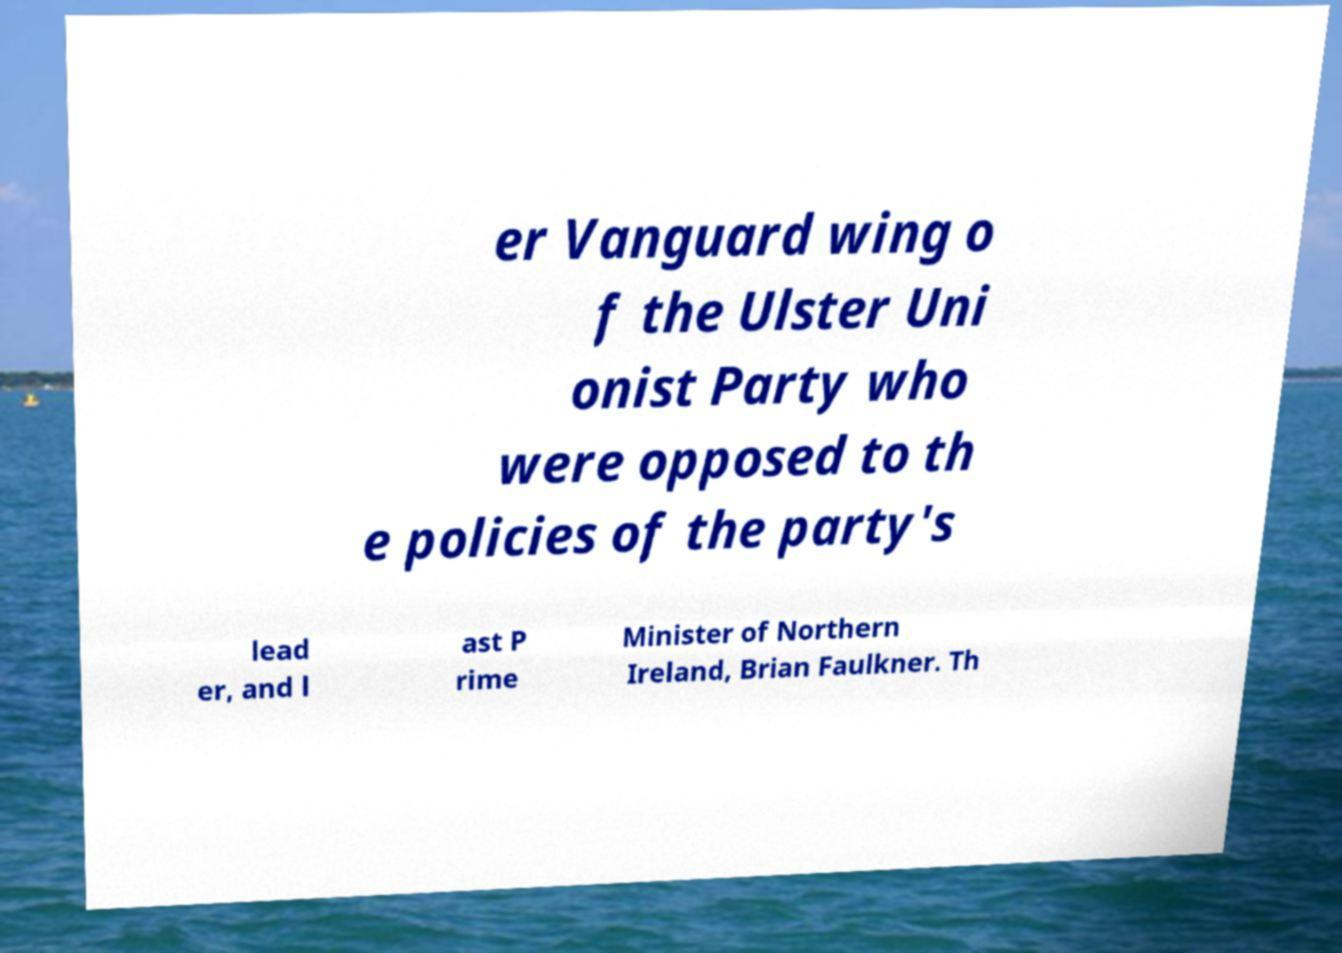For documentation purposes, I need the text within this image transcribed. Could you provide that? er Vanguard wing o f the Ulster Uni onist Party who were opposed to th e policies of the party's lead er, and l ast P rime Minister of Northern Ireland, Brian Faulkner. Th 